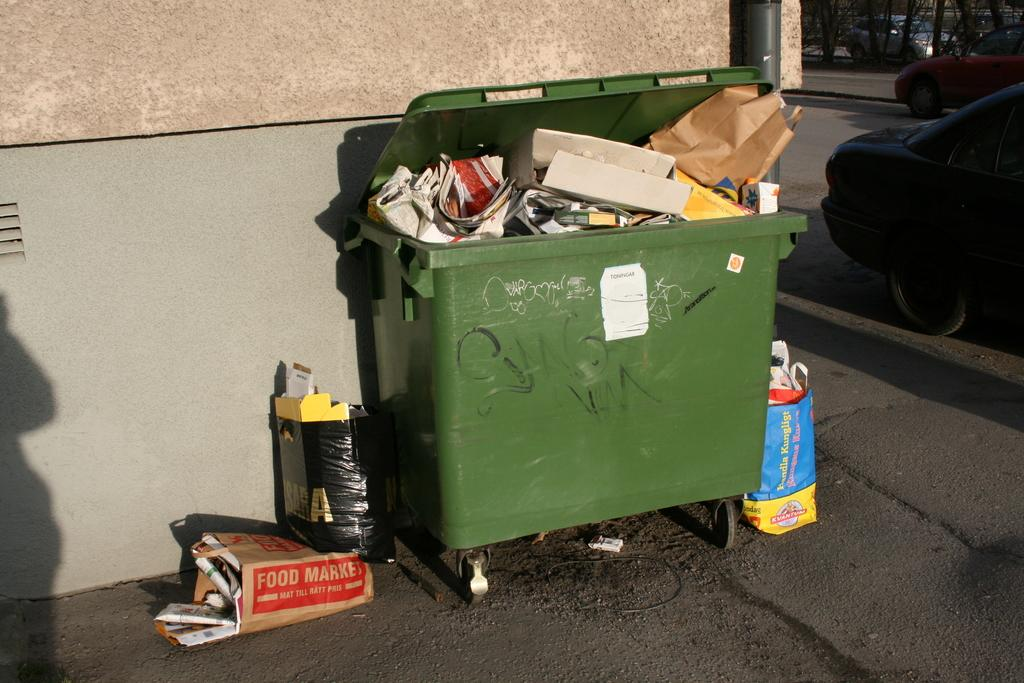Provide a one-sentence caption for the provided image. A brown paper bag from the Food Market is laying next to a green dumpster. 